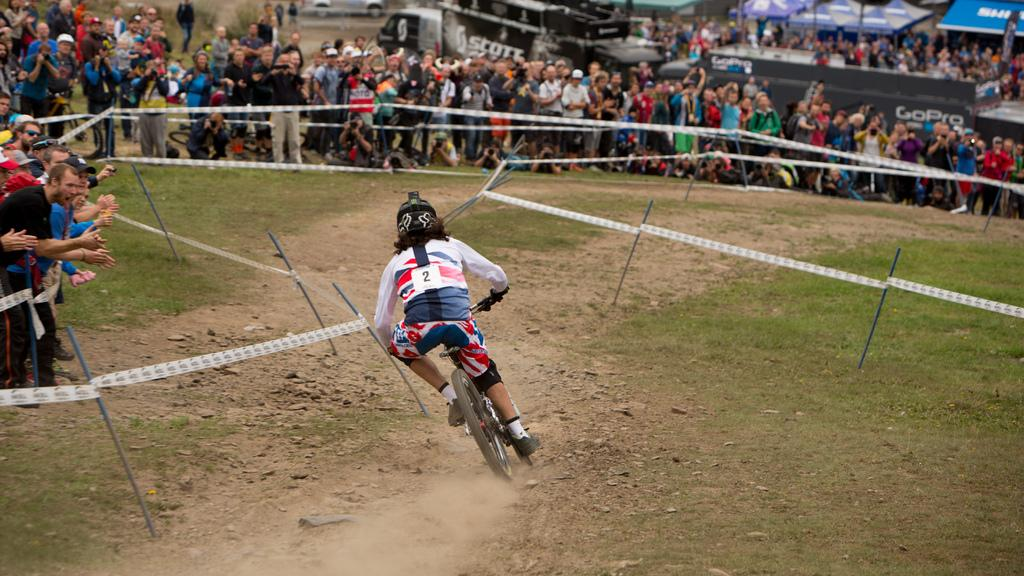<image>
Give a short and clear explanation of the subsequent image. Person racing on a bike with a number 2 on their back. 